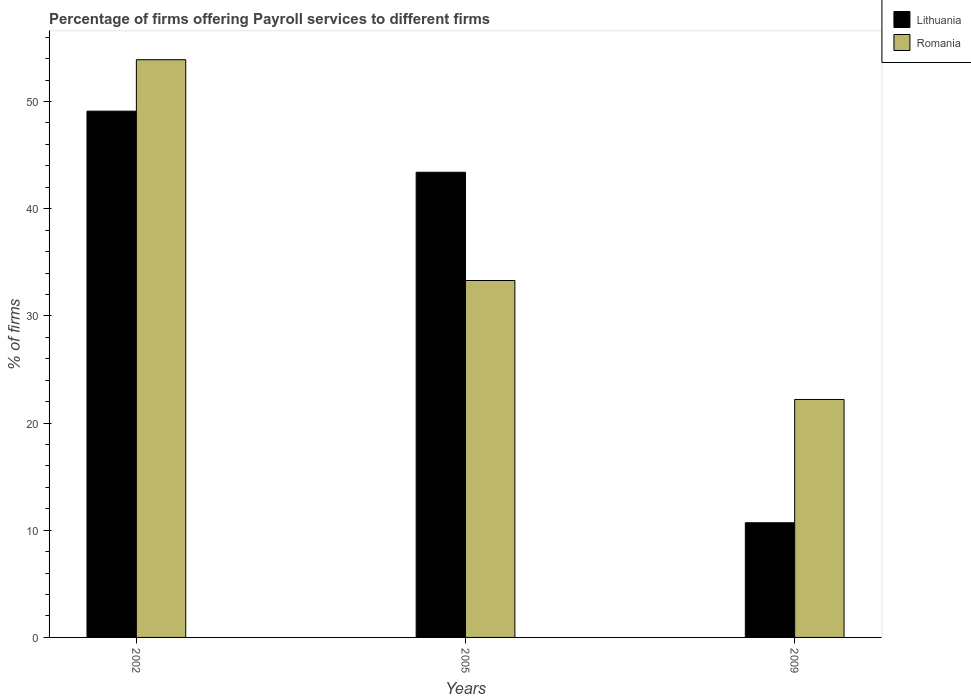How many different coloured bars are there?
Give a very brief answer. 2. How many groups of bars are there?
Ensure brevity in your answer.  3. How many bars are there on the 2nd tick from the left?
Provide a short and direct response. 2. In how many cases, is the number of bars for a given year not equal to the number of legend labels?
Keep it short and to the point. 0. What is the percentage of firms offering payroll services in Romania in 2005?
Offer a very short reply. 33.3. Across all years, what is the maximum percentage of firms offering payroll services in Lithuania?
Make the answer very short. 49.1. Across all years, what is the minimum percentage of firms offering payroll services in Romania?
Make the answer very short. 22.2. In which year was the percentage of firms offering payroll services in Lithuania maximum?
Your answer should be very brief. 2002. In which year was the percentage of firms offering payroll services in Romania minimum?
Offer a terse response. 2009. What is the total percentage of firms offering payroll services in Lithuania in the graph?
Give a very brief answer. 103.2. What is the difference between the percentage of firms offering payroll services in Lithuania in 2005 and that in 2009?
Give a very brief answer. 32.7. What is the difference between the percentage of firms offering payroll services in Romania in 2005 and the percentage of firms offering payroll services in Lithuania in 2009?
Keep it short and to the point. 22.6. What is the average percentage of firms offering payroll services in Lithuania per year?
Provide a short and direct response. 34.4. In the year 2002, what is the difference between the percentage of firms offering payroll services in Romania and percentage of firms offering payroll services in Lithuania?
Your response must be concise. 4.8. In how many years, is the percentage of firms offering payroll services in Lithuania greater than 28 %?
Keep it short and to the point. 2. What is the ratio of the percentage of firms offering payroll services in Romania in 2005 to that in 2009?
Provide a succinct answer. 1.5. Is the difference between the percentage of firms offering payroll services in Romania in 2002 and 2005 greater than the difference between the percentage of firms offering payroll services in Lithuania in 2002 and 2005?
Offer a terse response. Yes. What is the difference between the highest and the second highest percentage of firms offering payroll services in Lithuania?
Your answer should be very brief. 5.7. What is the difference between the highest and the lowest percentage of firms offering payroll services in Romania?
Ensure brevity in your answer.  31.7. In how many years, is the percentage of firms offering payroll services in Romania greater than the average percentage of firms offering payroll services in Romania taken over all years?
Provide a short and direct response. 1. Is the sum of the percentage of firms offering payroll services in Lithuania in 2002 and 2009 greater than the maximum percentage of firms offering payroll services in Romania across all years?
Provide a short and direct response. Yes. What does the 2nd bar from the left in 2002 represents?
Keep it short and to the point. Romania. What does the 2nd bar from the right in 2002 represents?
Your answer should be compact. Lithuania. Are all the bars in the graph horizontal?
Your answer should be compact. No. Does the graph contain any zero values?
Offer a terse response. No. What is the title of the graph?
Offer a very short reply. Percentage of firms offering Payroll services to different firms. Does "Tuvalu" appear as one of the legend labels in the graph?
Offer a terse response. No. What is the label or title of the Y-axis?
Make the answer very short. % of firms. What is the % of firms in Lithuania in 2002?
Ensure brevity in your answer.  49.1. What is the % of firms of Romania in 2002?
Provide a short and direct response. 53.9. What is the % of firms of Lithuania in 2005?
Your response must be concise. 43.4. What is the % of firms of Romania in 2005?
Ensure brevity in your answer.  33.3. What is the % of firms of Lithuania in 2009?
Keep it short and to the point. 10.7. Across all years, what is the maximum % of firms in Lithuania?
Your response must be concise. 49.1. Across all years, what is the maximum % of firms in Romania?
Keep it short and to the point. 53.9. Across all years, what is the minimum % of firms of Lithuania?
Your response must be concise. 10.7. What is the total % of firms of Lithuania in the graph?
Provide a short and direct response. 103.2. What is the total % of firms of Romania in the graph?
Your response must be concise. 109.4. What is the difference between the % of firms of Romania in 2002 and that in 2005?
Give a very brief answer. 20.6. What is the difference between the % of firms in Lithuania in 2002 and that in 2009?
Your answer should be compact. 38.4. What is the difference between the % of firms of Romania in 2002 and that in 2009?
Your answer should be compact. 31.7. What is the difference between the % of firms of Lithuania in 2005 and that in 2009?
Your answer should be compact. 32.7. What is the difference between the % of firms of Lithuania in 2002 and the % of firms of Romania in 2009?
Provide a short and direct response. 26.9. What is the difference between the % of firms of Lithuania in 2005 and the % of firms of Romania in 2009?
Offer a terse response. 21.2. What is the average % of firms of Lithuania per year?
Make the answer very short. 34.4. What is the average % of firms in Romania per year?
Offer a very short reply. 36.47. In the year 2002, what is the difference between the % of firms in Lithuania and % of firms in Romania?
Keep it short and to the point. -4.8. In the year 2005, what is the difference between the % of firms in Lithuania and % of firms in Romania?
Provide a succinct answer. 10.1. What is the ratio of the % of firms of Lithuania in 2002 to that in 2005?
Provide a short and direct response. 1.13. What is the ratio of the % of firms in Romania in 2002 to that in 2005?
Provide a succinct answer. 1.62. What is the ratio of the % of firms of Lithuania in 2002 to that in 2009?
Offer a terse response. 4.59. What is the ratio of the % of firms in Romania in 2002 to that in 2009?
Keep it short and to the point. 2.43. What is the ratio of the % of firms in Lithuania in 2005 to that in 2009?
Your response must be concise. 4.06. What is the ratio of the % of firms in Romania in 2005 to that in 2009?
Your response must be concise. 1.5. What is the difference between the highest and the second highest % of firms in Romania?
Keep it short and to the point. 20.6. What is the difference between the highest and the lowest % of firms in Lithuania?
Offer a terse response. 38.4. What is the difference between the highest and the lowest % of firms of Romania?
Provide a short and direct response. 31.7. 